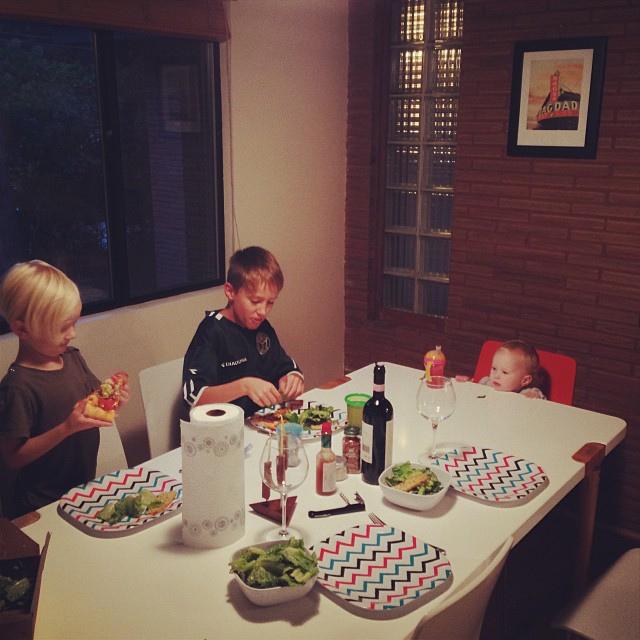Are there any adults pictured?
Concise answer only. No. What is in the bottle?
Write a very short answer. Wine. What is in the bowl?
Keep it brief. Salad. What product is inappropriate considering the age of the patrons in this picture?
Keep it brief. Wine. What type of place is this?
Concise answer only. Dining room. What type of design is on the plates?
Answer briefly. Zig zag. What are they sitting?
Write a very short answer. Table. How many people are shown?
Quick response, please. 3. What color is the plate?
Keep it brief. Multi. 